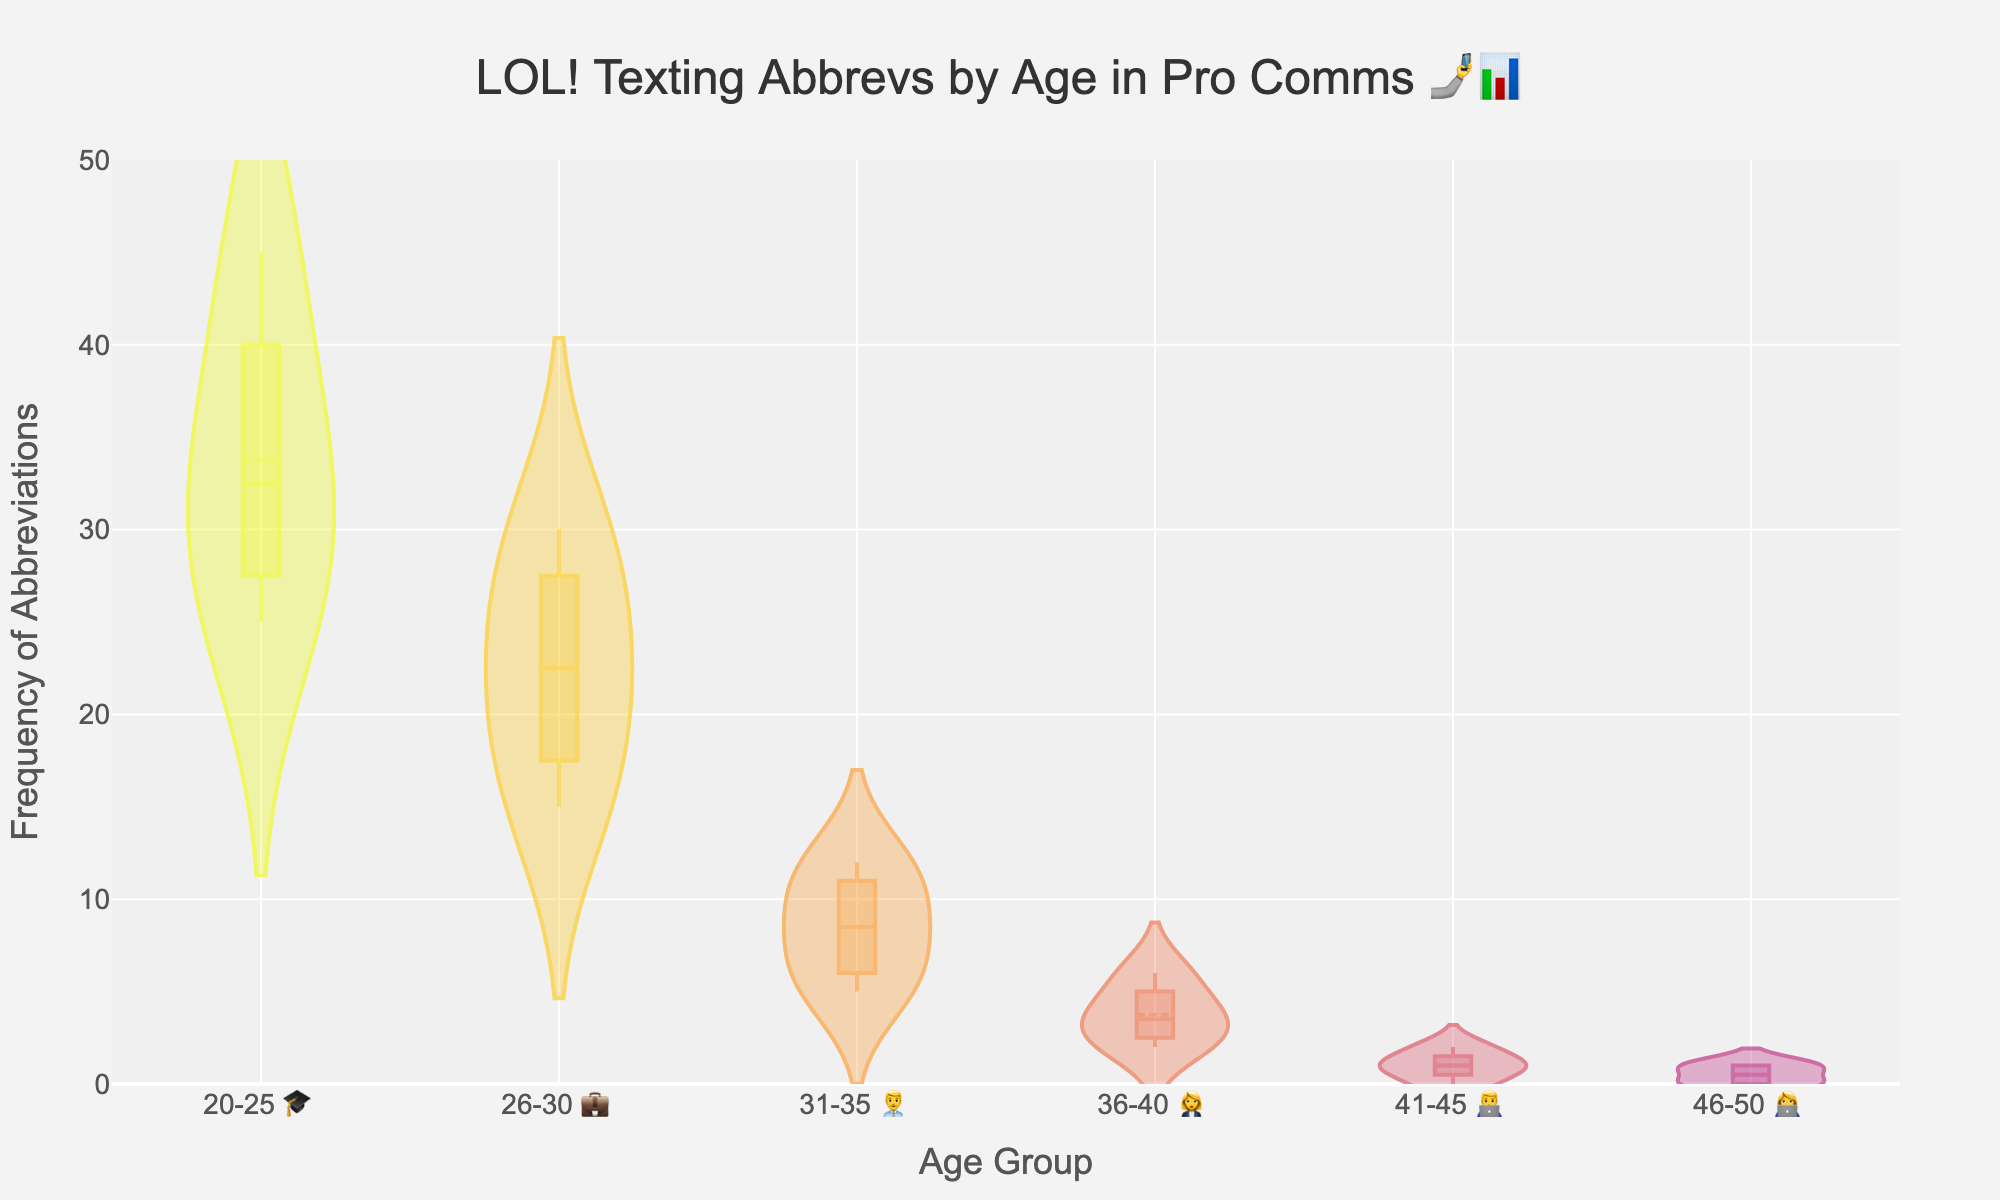What is the title of this density plot? The title is displayed at the top of the plot. It reads: "LOL! Texting Abbrevs by Age in Pro Comms 🤳📊"
Answer: LOL! Texting Abbrevs by Age in Pro Comms 🤳📊 What is the x-axis label? The x-axis label is provided below the axis of the plot. It reads: "Age Group"
Answer: Age Group What is the y-axis label? The y-axis label is provided to the left of the axis of the plot. It reads: "Frequency of Abbreviations"
Answer: Frequency of Abbreviations Which age group shows the highest average frequency of texting abbreviations? To find the highest average, look at the mean lines on the violins. The 20-25 age group has the highest mean line among all.
Answer: 20-25 How does the abbreviation frequency change with age? By observing the mean lines and general shape of the violins, the frequency decreases as the age group increases.
Answer: Decreases with age What is the average frequency of abbreviations used by the 31-35 age group? The average frequency for each group is shown by the mean line in the violin plot. The 31-35 age group has an average frequency close to 8.5.
Answer: Around 8.5 Compare the median frequency of abbreviations for the 26-30 and 36-40 age groups. The median can be found in the middle of each violin. The 26-30 group has a higher median compared to the 36-40 group.
Answer: 26-30 > 36-40 Which two age groups have the closest average frequency of texting abbreviations? By looking at the heights of the mean lines, the 41-45 and 46-50 age groups have nearly the same average frequency, both very low.
Answer: 41-45, 46-50 What is the range of abbreviation frequencies in the 20-25 age group? The range can be seen from the bottom to the top of the violin plot. For the 20-25 group, it ranges from 25 to 45.
Answer: 25-45 How many emojis are used in the x-axis labels and what do they represent? Count the number of emojis in the x-axis labels. There are 8 emojis, each aligned with an age group: 🎓 (20-25), 💼 (26-30), 👨‍💼 (31-35), 👩‍💼 (36-40), 🧓 (41-45), 👵 (46-50).
Answer: 8 emojis, represent age groups 